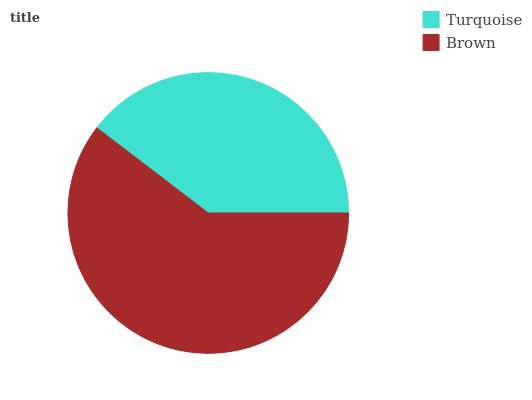Is Turquoise the minimum?
Answer yes or no. Yes. Is Brown the maximum?
Answer yes or no. Yes. Is Brown the minimum?
Answer yes or no. No. Is Brown greater than Turquoise?
Answer yes or no. Yes. Is Turquoise less than Brown?
Answer yes or no. Yes. Is Turquoise greater than Brown?
Answer yes or no. No. Is Brown less than Turquoise?
Answer yes or no. No. Is Brown the high median?
Answer yes or no. Yes. Is Turquoise the low median?
Answer yes or no. Yes. Is Turquoise the high median?
Answer yes or no. No. Is Brown the low median?
Answer yes or no. No. 